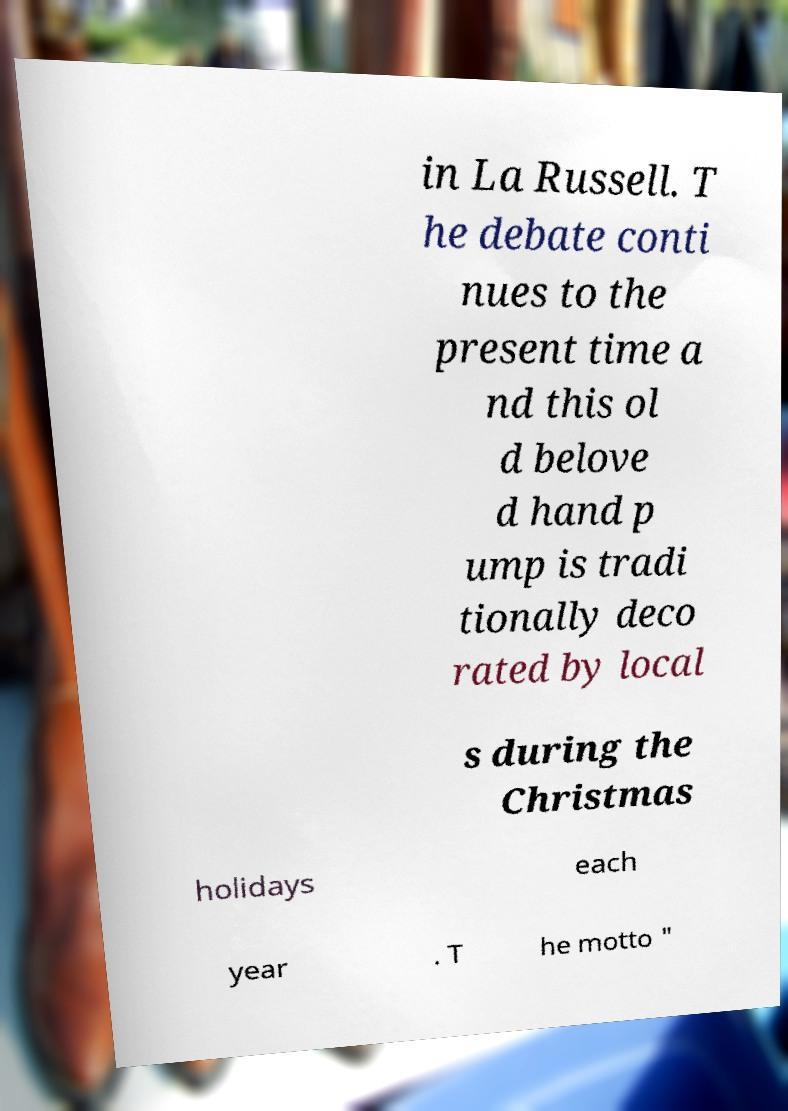There's text embedded in this image that I need extracted. Can you transcribe it verbatim? in La Russell. T he debate conti nues to the present time a nd this ol d belove d hand p ump is tradi tionally deco rated by local s during the Christmas holidays each year . T he motto " 